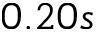<formula> <loc_0><loc_0><loc_500><loc_500>0 . 2 0 s</formula> 